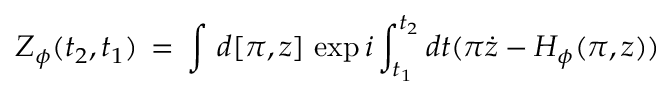<formula> <loc_0><loc_0><loc_500><loc_500>Z _ { \phi } ( t _ { 2 } , t _ { 1 } ) \, = \, \int \, d [ \pi , z ] \, \exp i \int _ { t _ { 1 } } ^ { t _ { 2 } } d t ( \pi \dot { z } - H _ { \phi } ( \pi , z ) )</formula> 